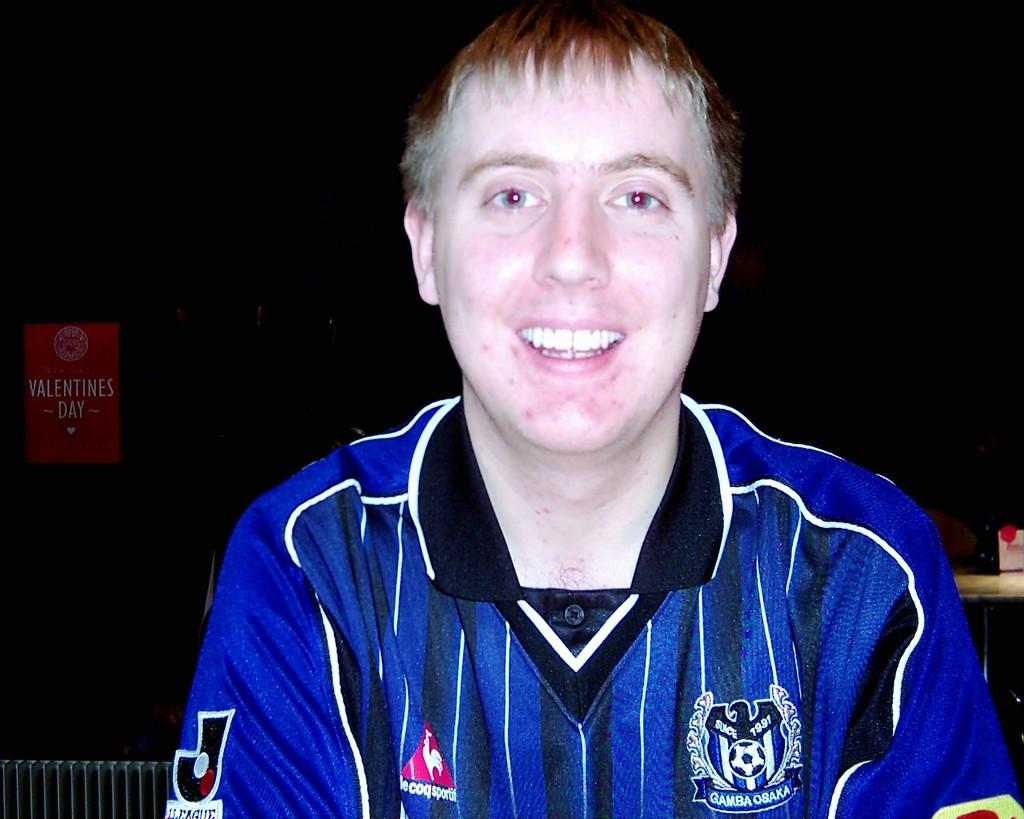<image>
Provide a brief description of the given image. a man wearing a socker jersey labeled Gamba osaka 